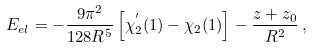Convert formula to latex. <formula><loc_0><loc_0><loc_500><loc_500>E _ { e l } = - \frac { 9 \pi ^ { 2 } } { 1 2 8 R ^ { 5 } } \left [ \chi _ { 2 } ^ { ^ { \prime } } ( 1 ) - \chi _ { 2 } ( 1 ) \right ] - \frac { z + z _ { 0 } } { R ^ { 2 } } \, ,</formula> 